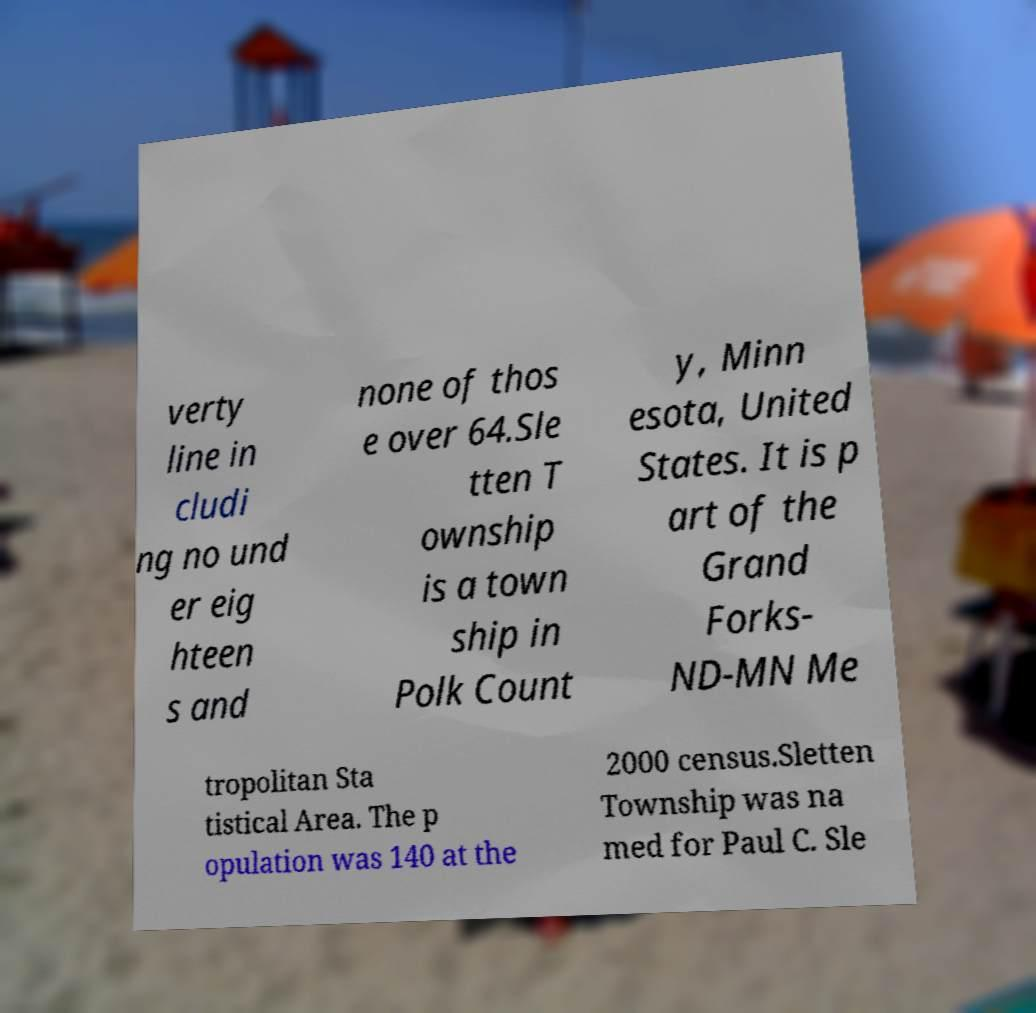I need the written content from this picture converted into text. Can you do that? verty line in cludi ng no und er eig hteen s and none of thos e over 64.Sle tten T ownship is a town ship in Polk Count y, Minn esota, United States. It is p art of the Grand Forks- ND-MN Me tropolitan Sta tistical Area. The p opulation was 140 at the 2000 census.Sletten Township was na med for Paul C. Sle 